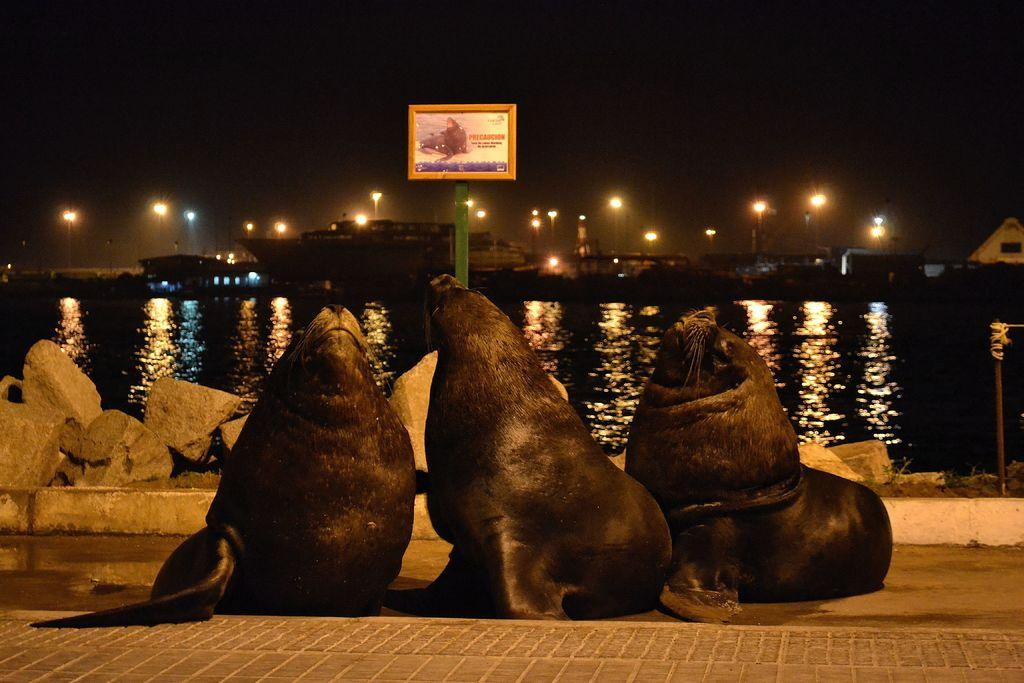How many seals can be seen in the image? There are three seals on the ground in the image. What else is present on the ground in the image? Stones are present in the image. What is visible in the background of the image? The sky is visible in the background of the image. What type of structure can be seen in the image? There is a board in the image. What is the primary source of light in the image? Lights are visible in the image. Can you see a robin using the whip to join the seals in the image? There is no robin or whip present in the image. 